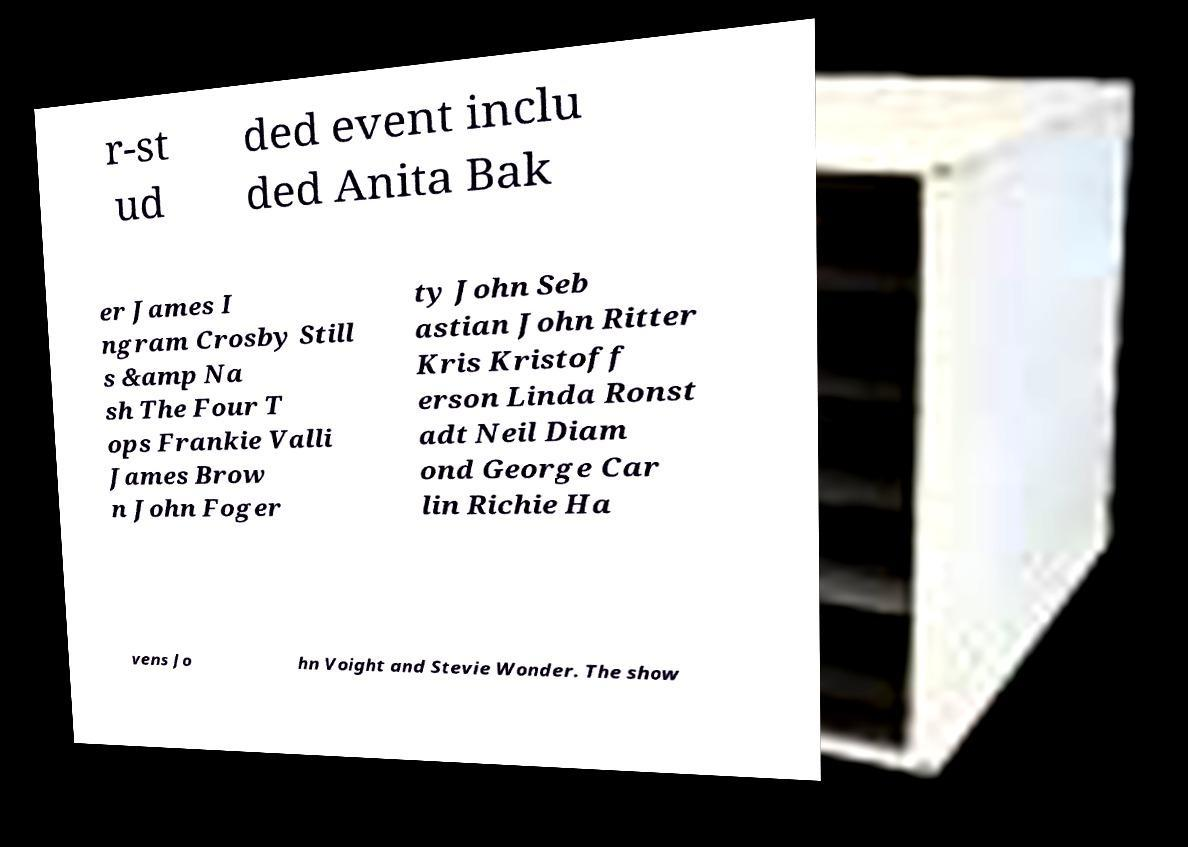There's text embedded in this image that I need extracted. Can you transcribe it verbatim? r-st ud ded event inclu ded Anita Bak er James I ngram Crosby Still s &amp Na sh The Four T ops Frankie Valli James Brow n John Foger ty John Seb astian John Ritter Kris Kristoff erson Linda Ronst adt Neil Diam ond George Car lin Richie Ha vens Jo hn Voight and Stevie Wonder. The show 